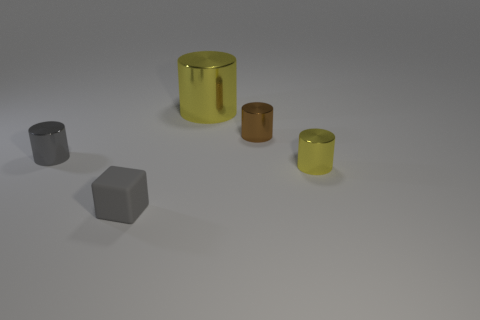Subtract all brown cylinders. Subtract all brown cubes. How many cylinders are left? 3 Add 2 big matte things. How many objects exist? 7 Subtract all cylinders. How many objects are left? 1 Subtract 0 green balls. How many objects are left? 5 Subtract all big brown spheres. Subtract all big yellow cylinders. How many objects are left? 4 Add 4 gray rubber objects. How many gray rubber objects are left? 5 Add 2 gray matte objects. How many gray matte objects exist? 3 